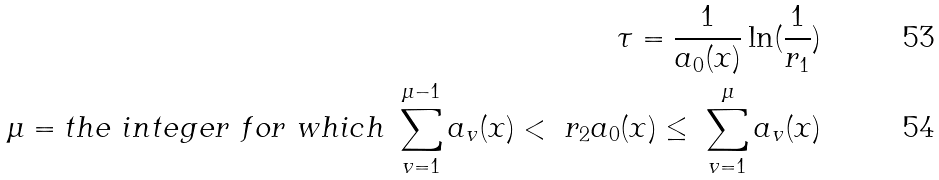Convert formula to latex. <formula><loc_0><loc_0><loc_500><loc_500>\tau = \frac { 1 } { a _ { 0 } ( x ) } \ln ( \frac { 1 } { r _ { 1 } } ) \\ \mu = t h e \ i n t e g e r \ f o r \ w h i c h \ \sum _ { v = 1 } ^ { \mu - 1 } a _ { v } ( x ) < \ r _ { 2 } a _ { 0 } ( x ) \leq \ \sum _ { v = 1 } ^ { \mu } a _ { v } ( x )</formula> 